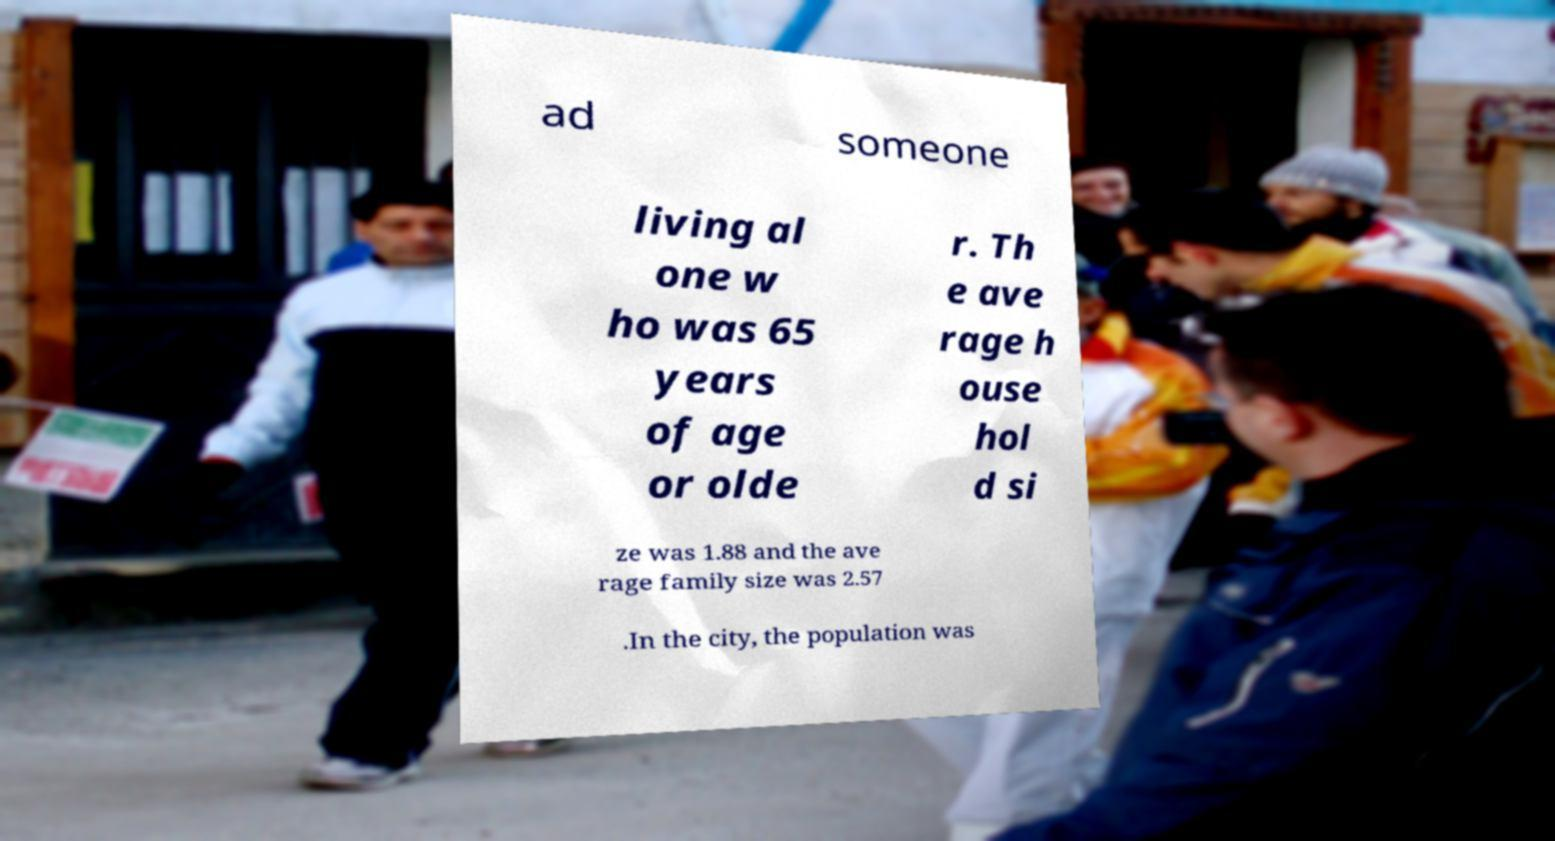Could you assist in decoding the text presented in this image and type it out clearly? ad someone living al one w ho was 65 years of age or olde r. Th e ave rage h ouse hol d si ze was 1.88 and the ave rage family size was 2.57 .In the city, the population was 